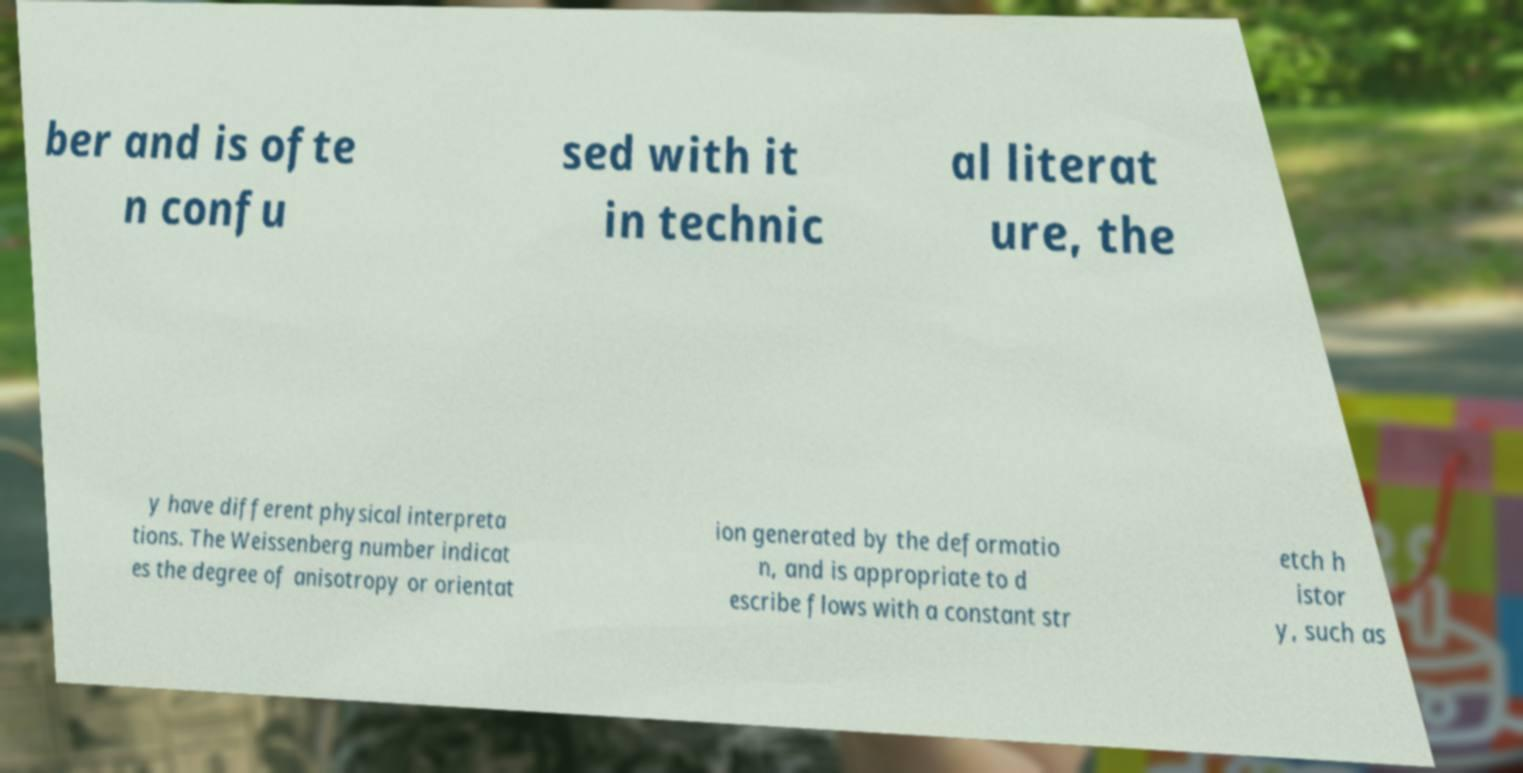Please read and relay the text visible in this image. What does it say? ber and is ofte n confu sed with it in technic al literat ure, the y have different physical interpreta tions. The Weissenberg number indicat es the degree of anisotropy or orientat ion generated by the deformatio n, and is appropriate to d escribe flows with a constant str etch h istor y, such as 